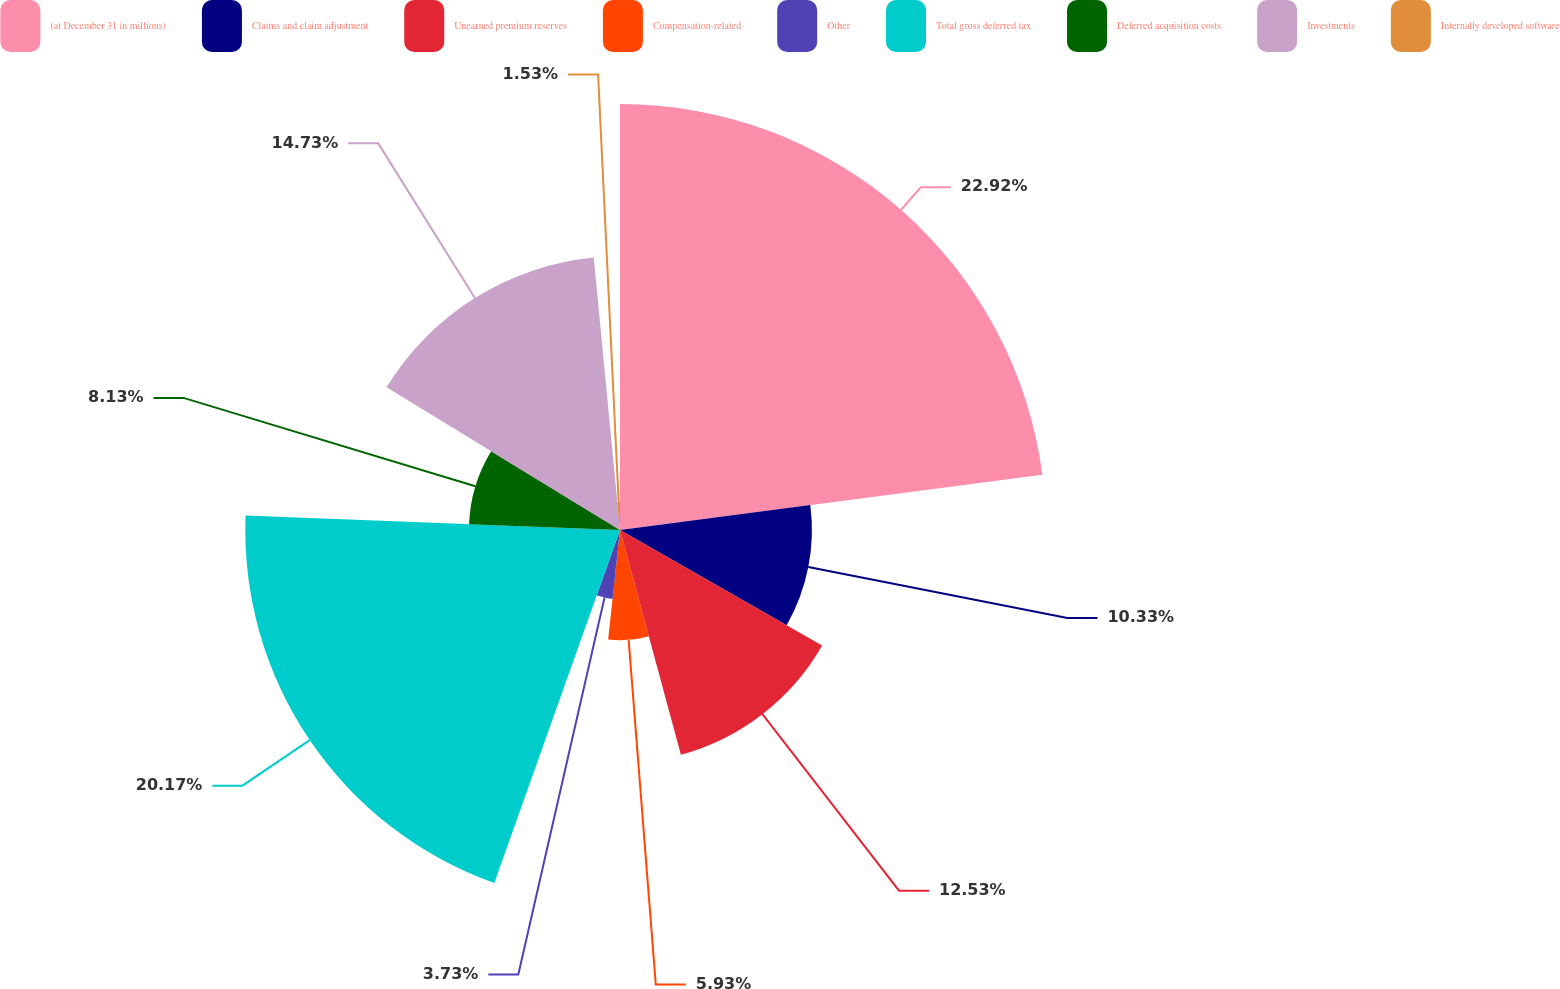Convert chart to OTSL. <chart><loc_0><loc_0><loc_500><loc_500><pie_chart><fcel>(at December 31 in millions)<fcel>Claims and claim adjustment<fcel>Unearned premium reserves<fcel>Compensation-related<fcel>Other<fcel>Total gross deferred tax<fcel>Deferred acquisition costs<fcel>Investments<fcel>Internally developed software<nl><fcel>22.93%<fcel>10.33%<fcel>12.53%<fcel>5.93%<fcel>3.73%<fcel>20.17%<fcel>8.13%<fcel>14.73%<fcel>1.53%<nl></chart> 